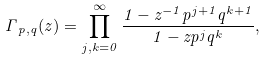Convert formula to latex. <formula><loc_0><loc_0><loc_500><loc_500>\Gamma _ { \, p , q } ( z ) = \prod _ { j , k = 0 } ^ { \infty } \frac { 1 - z ^ { - 1 } p ^ { j + 1 } q ^ { k + 1 } } { 1 - z p ^ { j } q ^ { k } } ,</formula> 